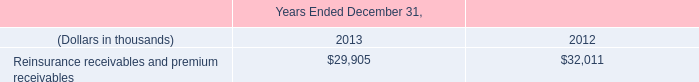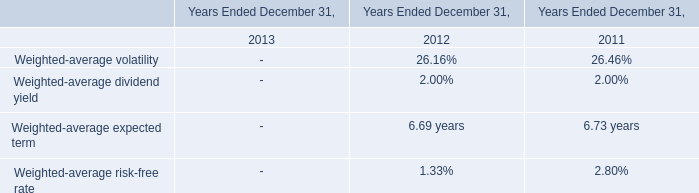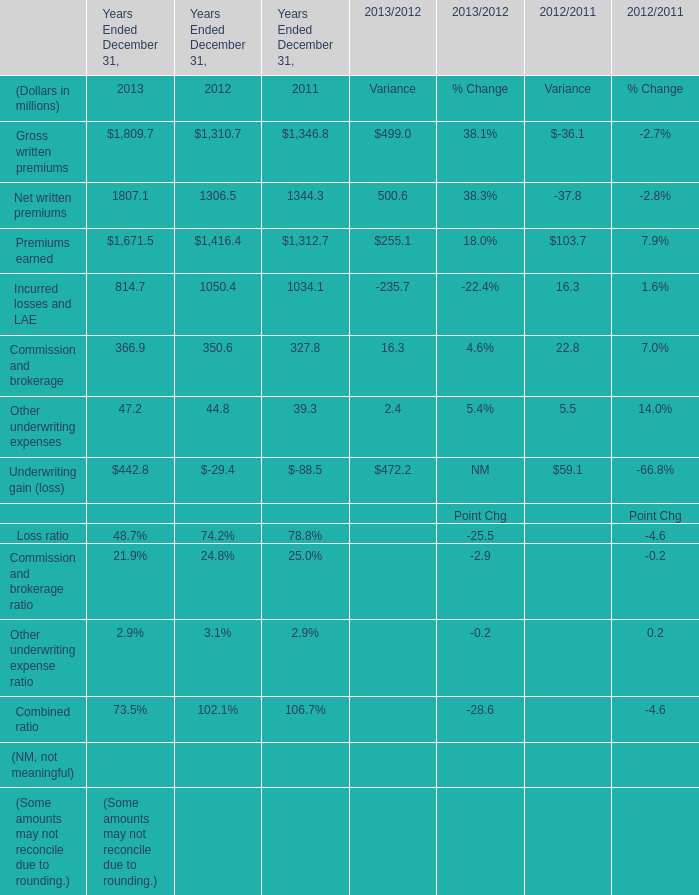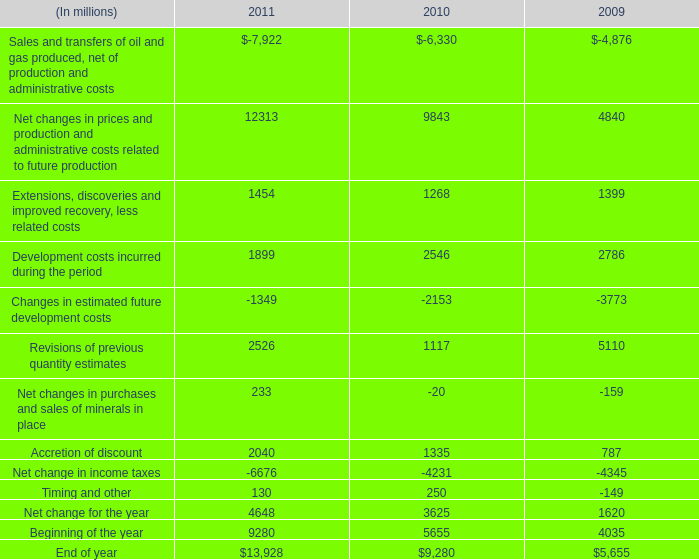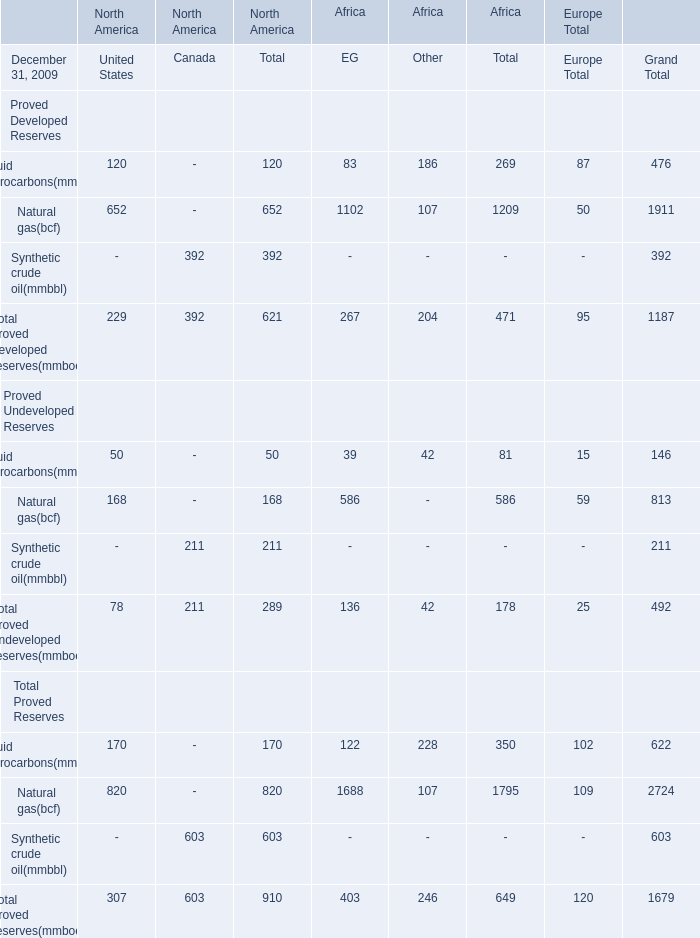What is the average amount of Net change for the year of 2010, and Premiums earned of Years Ended December 31, 2011 ? 
Computations: ((3625.0 + 1312.7) / 2)
Answer: 2468.85. 